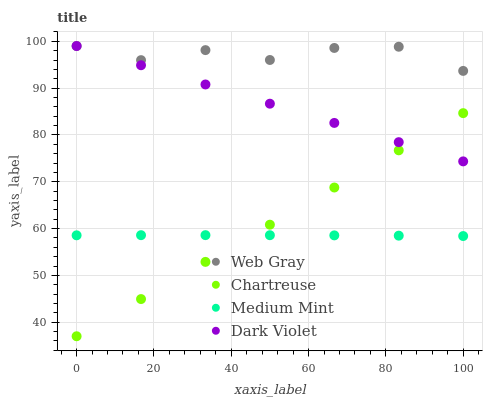Does Medium Mint have the minimum area under the curve?
Answer yes or no. Yes. Does Web Gray have the maximum area under the curve?
Answer yes or no. Yes. Does Chartreuse have the minimum area under the curve?
Answer yes or no. No. Does Chartreuse have the maximum area under the curve?
Answer yes or no. No. Is Chartreuse the smoothest?
Answer yes or no. Yes. Is Web Gray the roughest?
Answer yes or no. Yes. Is Web Gray the smoothest?
Answer yes or no. No. Is Chartreuse the roughest?
Answer yes or no. No. Does Chartreuse have the lowest value?
Answer yes or no. Yes. Does Web Gray have the lowest value?
Answer yes or no. No. Does Dark Violet have the highest value?
Answer yes or no. Yes. Does Chartreuse have the highest value?
Answer yes or no. No. Is Medium Mint less than Dark Violet?
Answer yes or no. Yes. Is Dark Violet greater than Medium Mint?
Answer yes or no. Yes. Does Web Gray intersect Dark Violet?
Answer yes or no. Yes. Is Web Gray less than Dark Violet?
Answer yes or no. No. Is Web Gray greater than Dark Violet?
Answer yes or no. No. Does Medium Mint intersect Dark Violet?
Answer yes or no. No. 